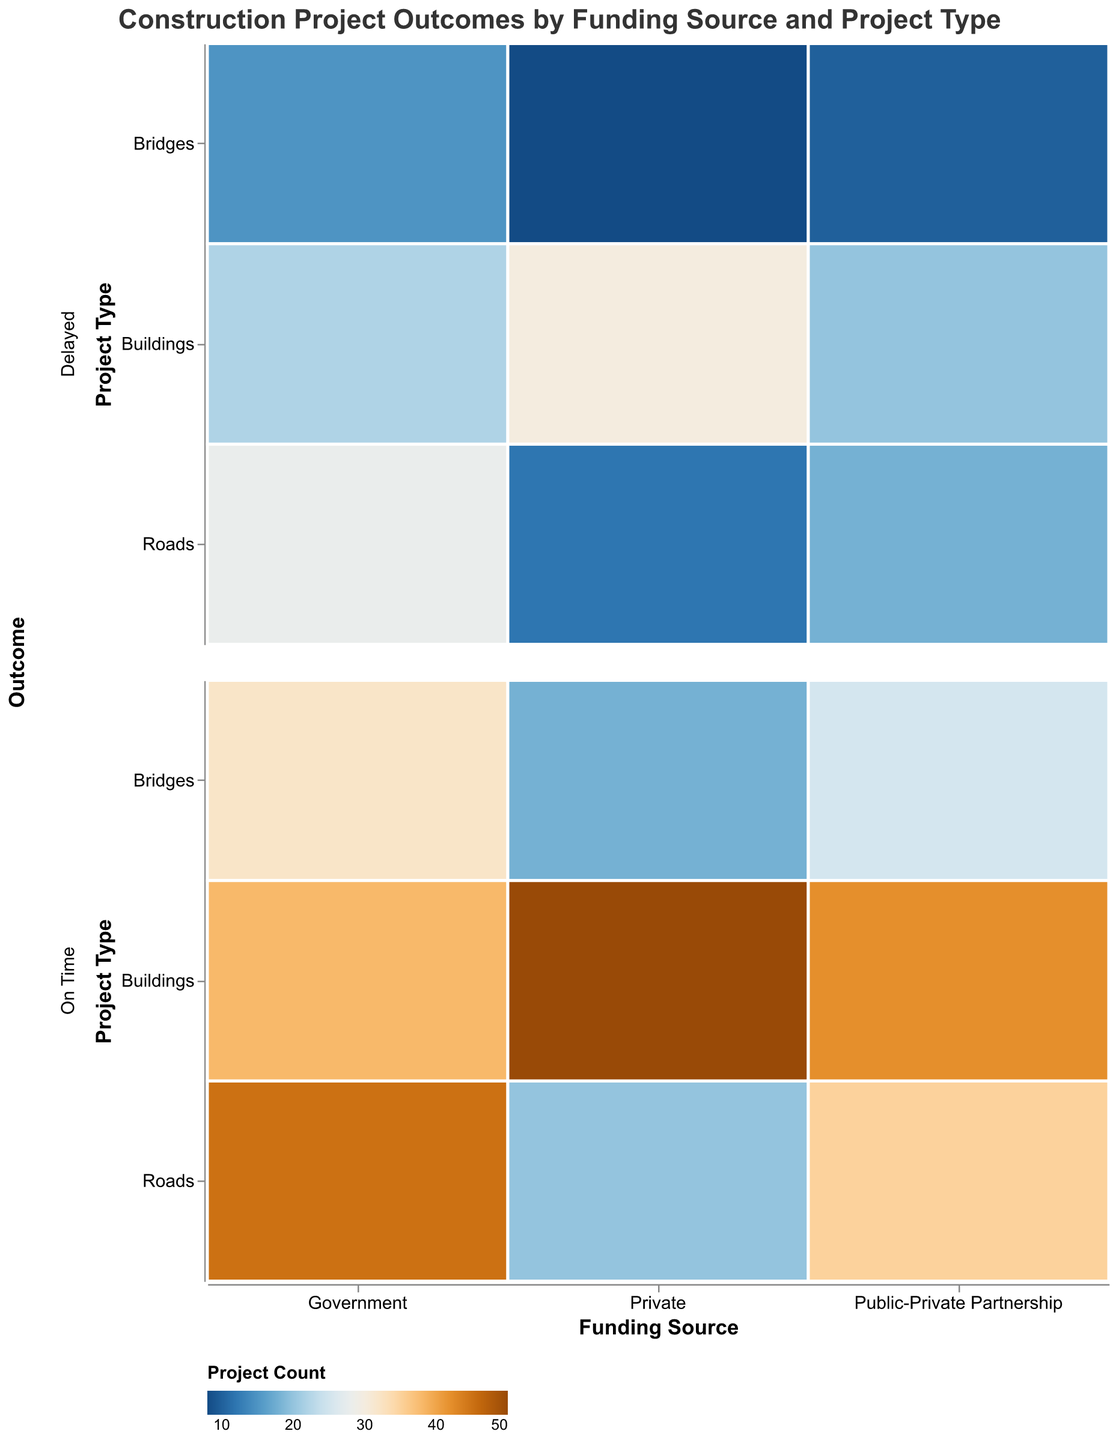What is the title of the figure? The title is always placed at the top of the figure and typically provides a succinct description of what the figure is about. In this case, the title is clearly visible.
Answer: Construction Project Outcomes by Funding Source and Project Type Which project type from government funding has the highest count of on-time outcomes? To find this, look at the segment with "Government" as the funding source, then check each project type for the "On Time" outcome to identify the highest count. Here, "Roads" has the on-time outcome count of 45, which is the highest.
Answer: Roads Which funding source has the highest total count of delayed projects? To determine this, sum up the counts of delayed projects for each funding source: Government (28+15+22), Private (12+8+30), and Public-Private Partnership (18+10+20). The funding source with the highest total is Government, with a total delayed count of 65.
Answer: Government Comparing private funding with public-private partnership funding, which has more on-time bridges projects? Look at the segments for "Bridges" under both "Private" and "Public-Private Partnership" funding and check the counts for the "On Time" outcome. "Private" has 18, while "Public-Private Partnership" has 25, so the latter has more on-time bridges projects.
Answer: Public-Private Partnership What is the color associated with the highest count of projects in the figure? The color representing the highest count would be the one allocated to rectangles with the largest numbers. Assuming a blueorange color scheme, typically the highest count would be towards the darker blue end. The highest count is 50, hence the darkest blue shade is used for it.
Answer: Dark blue What is the difference in on-time outcomes between private and public-private partnerships for building projects? Check the counts for "Buildings" with the "On Time" outcome under "Private" and "Public-Private Partnership". "Private" has 50, and "Public-Private Partnership" has 42. The difference is 50 - 42 = 8.
Answer: 8 Which project type has the least discrepancy in on-time outcomes between government and private funding? For this, calculate the difference in the counts of "On Time" outcomes for each project type. For "Roads" (45-20=25), "Bridges" (32-18=14), and "Buildings" (38-50=12). "Buildings" have the smallest discrepancy.
Answer: Buildings How many total delayed projects are there across all funding sources and project types? Sum all the delayed counts across different funding sources and project types which are: 28 + 15 + 22 + 12 + 8 + 30 + 18 + 10 + 20 = 163.
Answer: 163 For which type of project does public-private partnership funding most frequently lead to on-time outcomes? Check the counts for "On Time" outcomes under "Public-Private Partnership" for each project type. The highest count here is for "Buildings" with a count of 42.
Answer: Buildings 